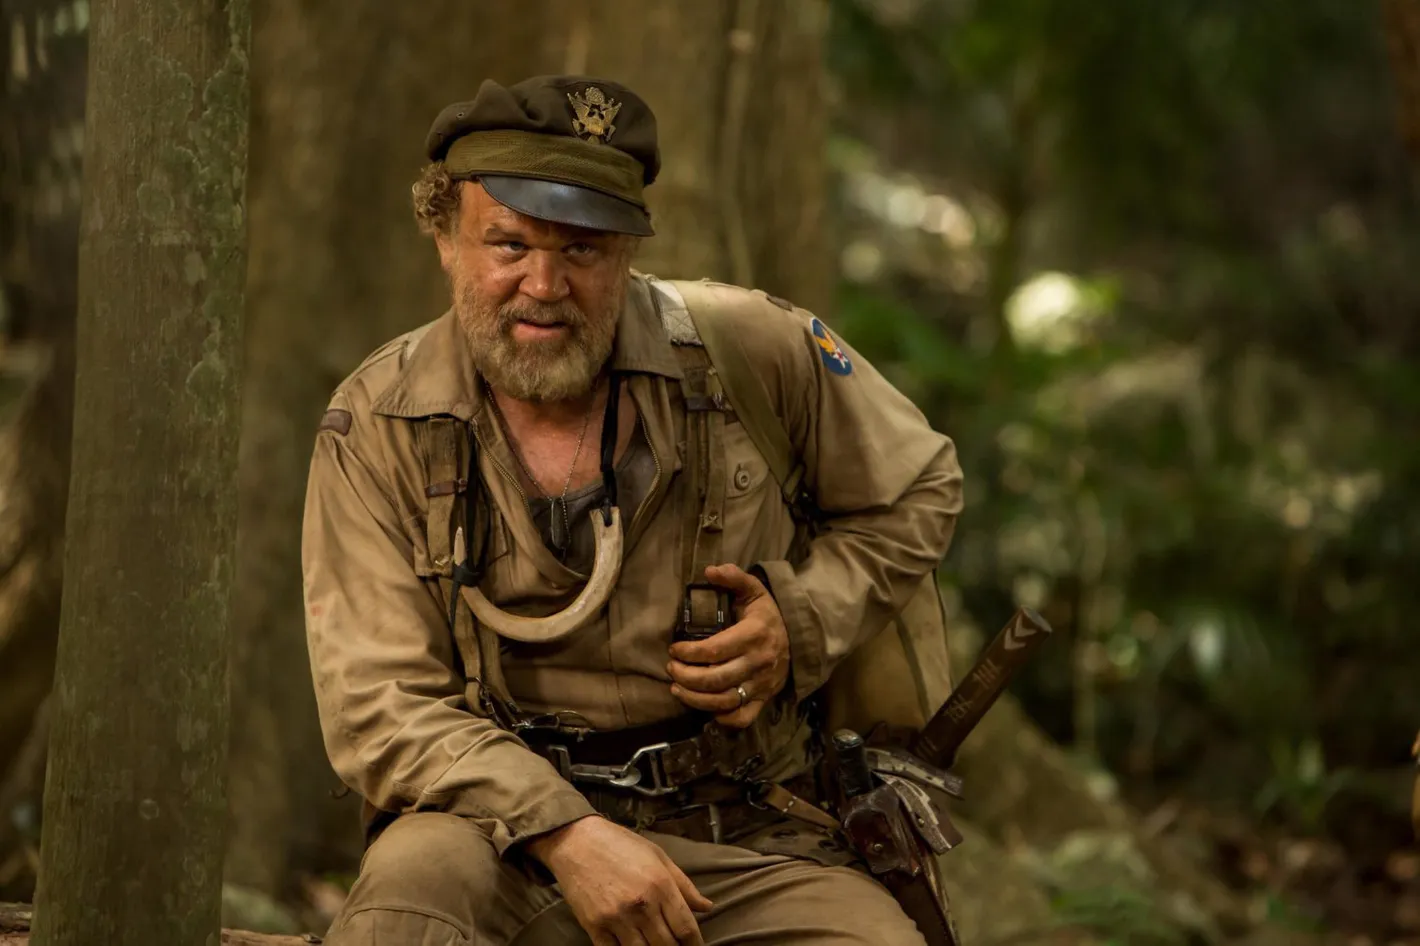Describe the setting of the image. The setting of the image is a dense, primordial jungle. Thick trees with rugged bark tower above, their leaves forming a thick canopy that filters the sunlight into a soft, green haze. The ground is littered with fallen leaves, branches, and the occasional underbrush that fights for sunlight. The air seems heavy with humidity, a typical tropical environment where the untouched wilderness thrives. The sounds of distant wildlife and the rustle of leaves in the breeze might be the only background noise, enveloping the scene in a serene yet wild atmosphere. What kinds of challenges does the character face in such an environment? In such a harsh and unforgiving environment, the character faces numerous challenges. Firstly, the dense foliage and rugged terrain make navigation difficult and physically demanding. The constant threat of wild animals adds an element of danger to every step taken. Additionally, the tropical environment means battling the elements - intense heat during the day and potentially cold and damp conditions at night. The availability of clean water and food is another significant concern, requiring the character to have extensive survival knowledge and skills. Furthermore, the mental toll of isolation and the ever-present sense of alertness needed to survive in such an environment can weigh heavily on the character's psyche. 